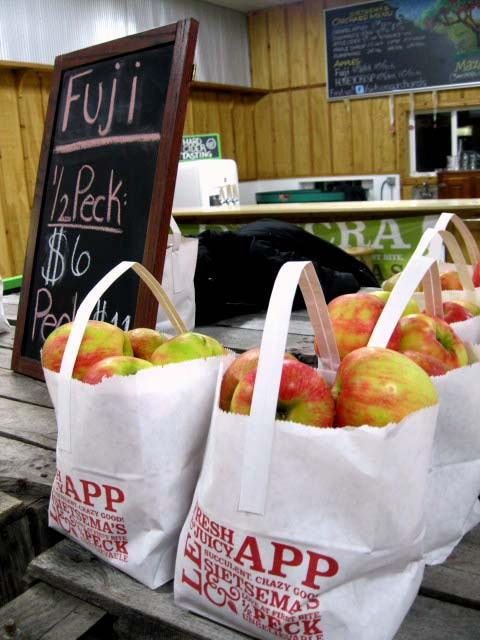What is the price for a bag of apples? According to the sign in the image, a bag of Fuji apples is priced at $6 for a half-peck. 